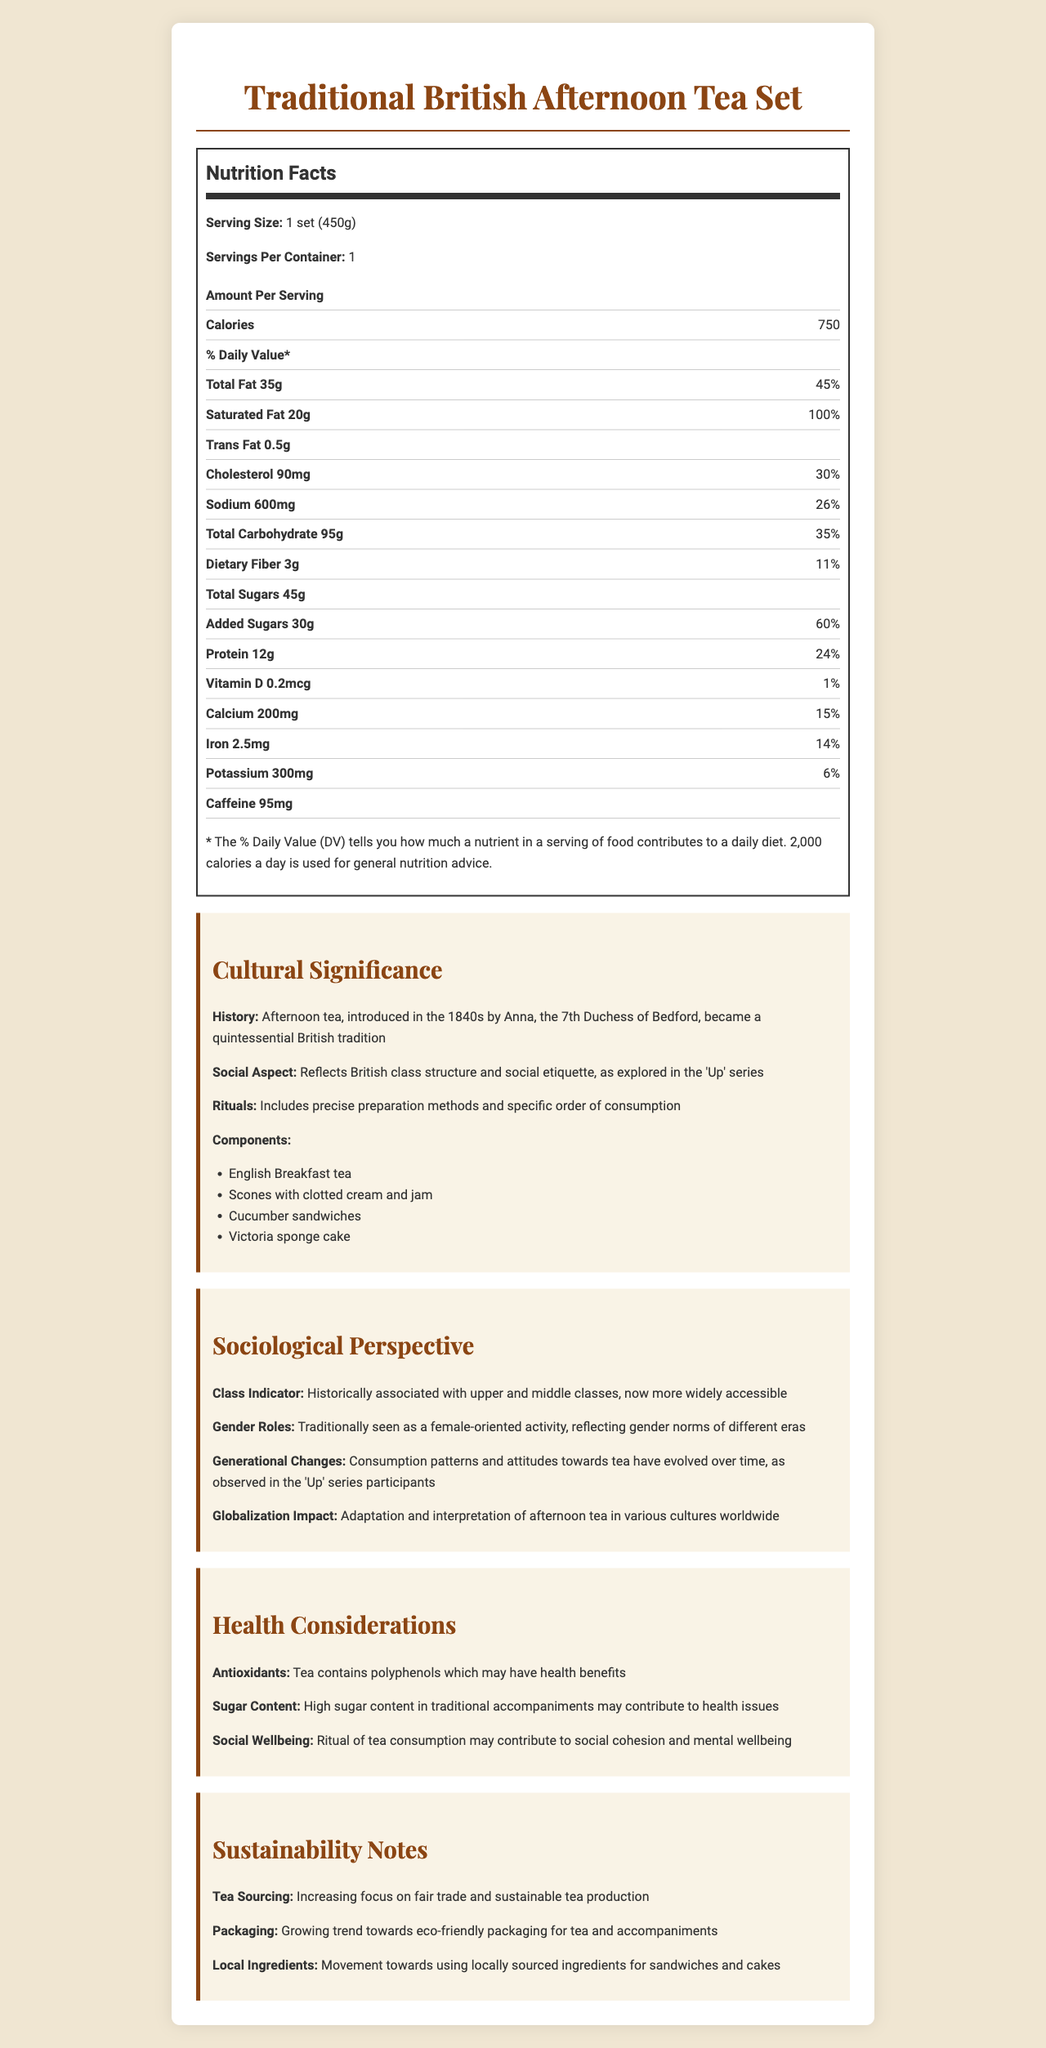what is the serving size for the Traditional British Afternoon Tea Set? The label indicates that the serving size is 1 set, which weighs 450 grams.
Answer: 1 set (450g) how many calories are in one serving of the tea set? The document says 750 calories per serving.
Answer: 750 what percentage of the daily value of saturated fat is in a serving? The label shows 20 grams of saturated fat, which is 100% of the daily value.
Answer: 100% how much protein does the tea set contain? According to the nutrition facts, the tea set contains 12 grams of protein.
Answer: 12g what is one of the health benefits associated with tea consumption mentioned in the document? The document mentions that tea contains polyphenols, which may have health benefits.
Answer: Antioxidants how much added sugars does the tea set have? The nutritional label lists 30 grams of added sugars per serving.
Answer: 30g how does the afternoon tea set reflect British social structure and etiquette? A. Through its ingredients B. Through precise preparation methods C. By reflecting British class structure and social etiquette D. By having low calories The document mentions that afternoon tea reflects British class structure and social etiquette.
Answer: C what are the main components of the Traditional British Afternoon Tea Set? A. Earl Grey tea, biscuits, scones, sandwiches B. English Breakfast tea, scones with clotted cream and jam, cucumber sandwiches, Victoria sponge cake C. Darjeeling tea, croissants, salmon sandwiches, fruit cake D. Green tea, biscuits, brownies, scones with jam The document lists English Breakfast tea, scones with clotted cream and jam, cucumber sandwiches, and Victoria sponge cake as the components.
Answer: B does the tea set contain trans fat? The document lists 0.5 grams of trans fat in the nutrition facts.
Answer: Yes is the Traditional British Afternoon Tea Set historically associated with the upper and middle classes? The sociological perspective section states that afternoon tea has historically been associated with upper and middle classes.
Answer: Yes what is the total carbohydrate content in the tea set? The nutrition facts show a total carbohydrate content of 95 grams.
Answer: 95g how much caffeine does the tea set contain? The document indicates there is 95 milligrams of caffeine in the tea set.
Answer: 95mg what are some of the sustainability practices mentioned in the document? The sustainability notes mention increasing focus on fair trade and sustainable tea production, eco-friendly packaging, and using locally sourced ingredients.
Answer: Fair trade tea sourcing, eco-friendly packaging, locally sourced ingredients what period did Anna, the 7th Duchess of Bedford, introduce afternoon tea? The cultural significance section states that afternoon tea was introduced in the 1840s by Anna, the 7th Duchess of Bedford.
Answer: 1840s how does the ritual of tea consumption potentially benefit mental wellbeing? The health considerations section suggests that the ritual of tea consumption may contribute to social cohesion and mental wellbeing.
Answer: Social cohesion and mental wellbeing describe the cultural and nutritional aspects of the Traditional British Afternoon Tea Set. The document covers the historical and cultural origins of afternoon tea, its sociological implications, health considerations, and sustainability practices. It provides a detailed breakdown of the tea set's nutritional content and explains how tea consumption fits into broader social and cultural contexts.
Answer: Afternoon tea is a traditional British custom introduced in the 1840s and known for its reflection of British class structure and social etiquette. It involves specific rituals and components like English Breakfast tea, scones with clotted cream and jam, cucumber sandwiches, and Victoria sponge cake. Nutritionally, one serving of the tea set contains 750 calories, 35g of total fat, 20g of saturated fat, and significant amounts of sugar and protein. It also offers health benefits through antioxidants in tea and poses some health concerns due to its high sugar content. what was the calorie content of the previous version of the afternoon tea set? The document does not provide any information about the calorie content of a previous version of the afternoon tea set.
Answer: Not enough information 